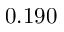<formula> <loc_0><loc_0><loc_500><loc_500>0 . 1 9 0</formula> 